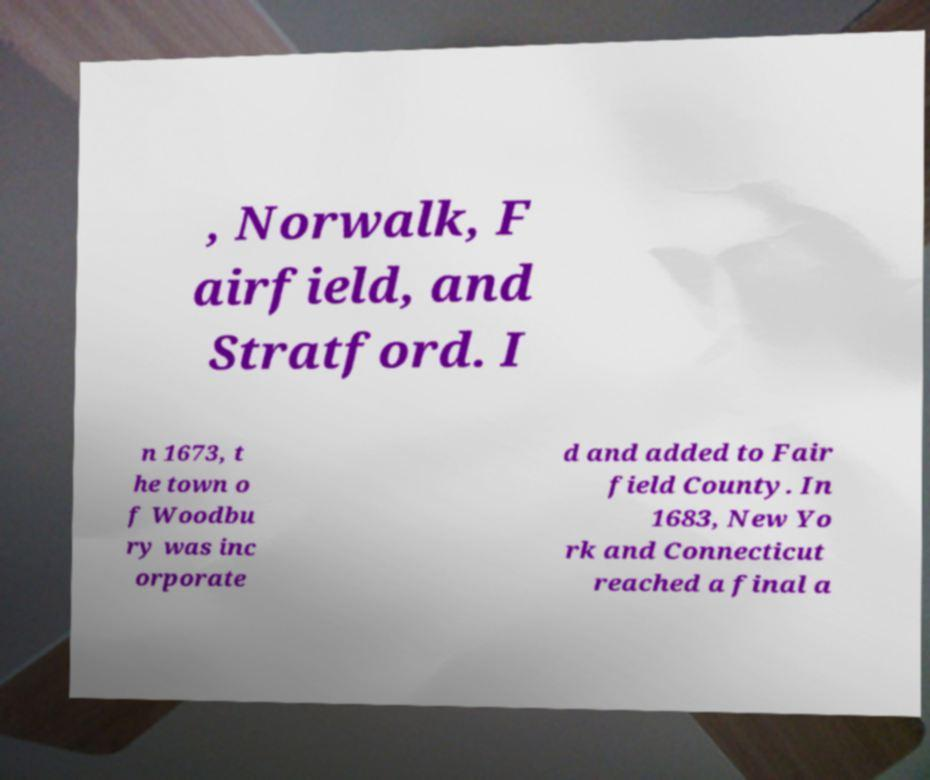Please identify and transcribe the text found in this image. , Norwalk, F airfield, and Stratford. I n 1673, t he town o f Woodbu ry was inc orporate d and added to Fair field County. In 1683, New Yo rk and Connecticut reached a final a 